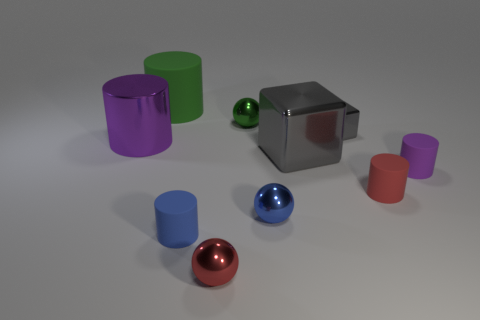Subtract all gray blocks. How many were subtracted if there are1gray blocks left? 1 Subtract all cyan blocks. How many purple cylinders are left? 2 Subtract all purple cylinders. How many cylinders are left? 3 Subtract all purple cylinders. How many cylinders are left? 3 Subtract all spheres. How many objects are left? 7 Subtract all purple spheres. Subtract all yellow cylinders. How many spheres are left? 3 Subtract all red metallic cylinders. Subtract all purple shiny things. How many objects are left? 9 Add 4 large purple metal things. How many large purple metal things are left? 5 Add 3 small red shiny balls. How many small red shiny balls exist? 4 Subtract 0 yellow cylinders. How many objects are left? 10 